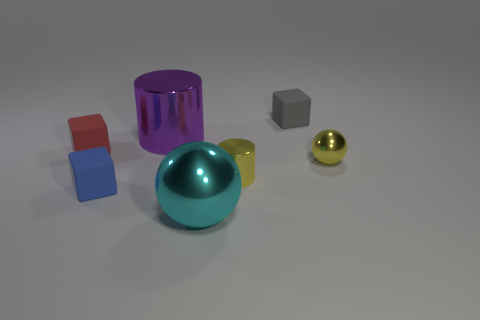Add 1 brown metallic cylinders. How many objects exist? 8 Subtract all cyan balls. How many balls are left? 1 Subtract 1 cylinders. How many cylinders are left? 1 Add 1 gray blocks. How many gray blocks are left? 2 Add 5 tiny gray things. How many tiny gray things exist? 6 Subtract 1 blue cubes. How many objects are left? 6 Subtract all balls. How many objects are left? 5 Subtract all blue balls. Subtract all green cylinders. How many balls are left? 2 Subtract all yellow cylinders. How many yellow balls are left? 1 Subtract all tiny blocks. Subtract all gray matte cubes. How many objects are left? 3 